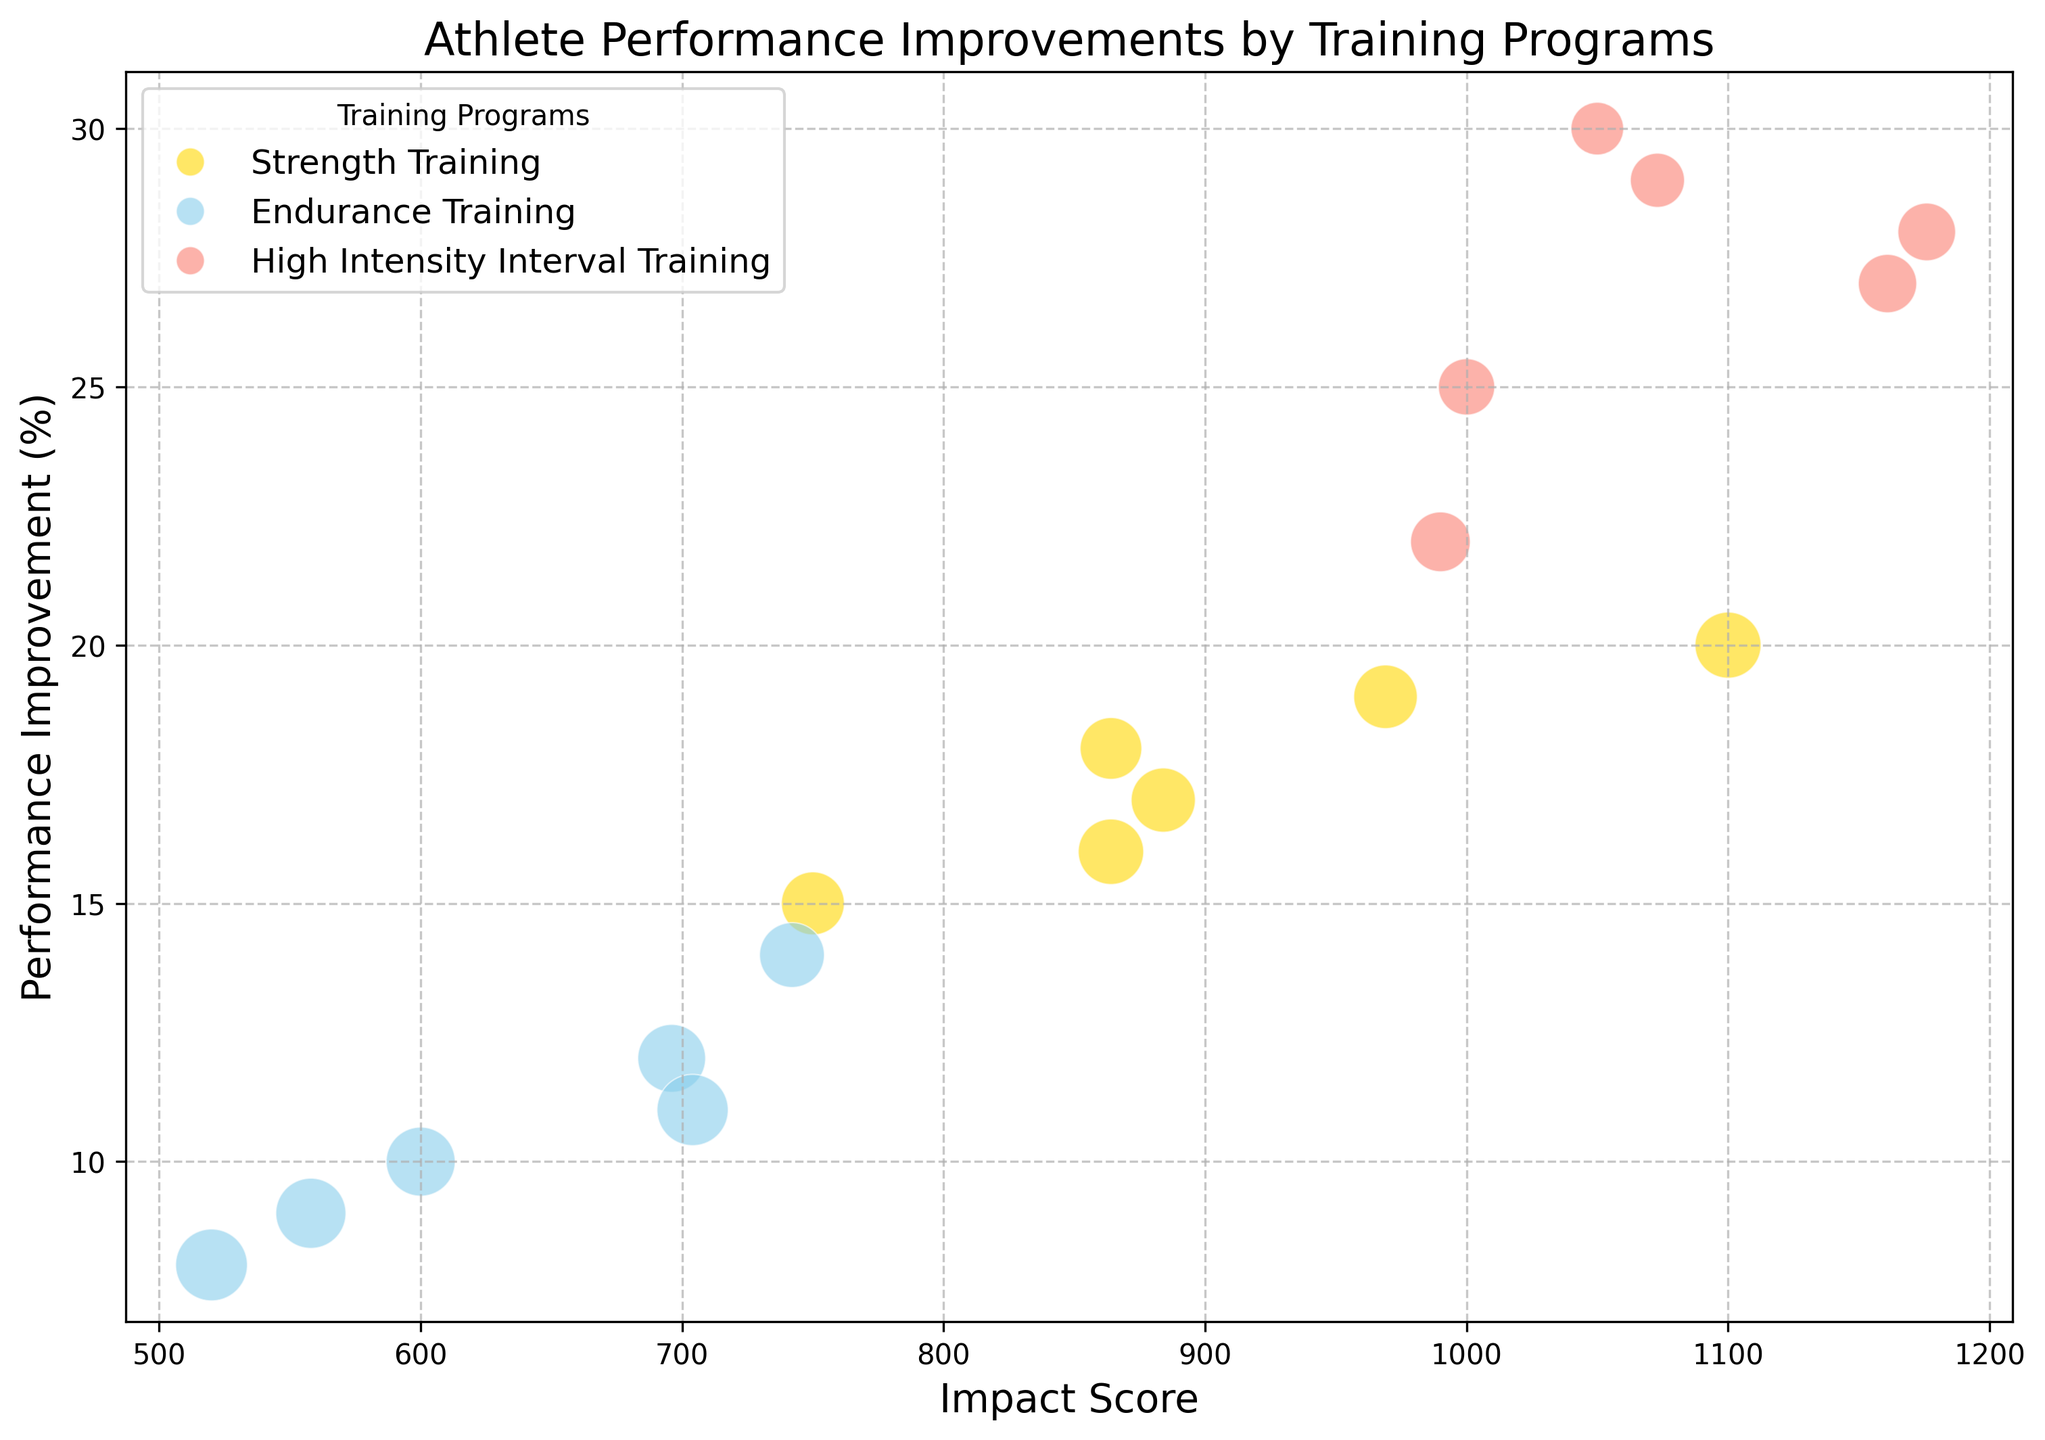What is the highest Performance Improvement observed among athletes? To find the highest Performance Improvement, we scan the vertical axis for the highest point. It appears to be associated with David White, showing a Performance Improvement of 30%.
Answer: 30% Which Training Program has the largest bubble size in general and what does it represent? Larger bubble size corresponds to higher Frequency. By examining the bubbles, the largest bubbles are generally found in the High Intensity Interval Training program. For instance, David White’s and Angela Lewis' bubbles are large.
Answer: High Intensity Interval Training What is the Performance Improvement for an athlete with the highest Impact Score? David White has the highest Impact Score of 1050. Scanning vertically from this point on the horizontal axis, we identify the Performance Improvement as 30%.
Answer: 30% Among athletes in Endurance Training, who shows the highest Performance Improvement and what is the value? Focusing on the blue bubbles representing Endurance Training, Robert Clark achieves the highest Performance Improvement with a value of 14%.
Answer: 14% Which Training Program has the widest range of Impact Scores? By examining the spread along the horizontal axis, High Intensity Interval Training presents the widest range, stretching from approximately 990 to 1176.
Answer: High Intensity Interval Training What is the average Performance Improvement of athletes in Strength Training program? Strength Training improvements are 15, 20, 18, 17, 19, 16. Summing these up yields 105. Divided by 6 athletes, the average is 105/6 = 17.5%.
Answer: 17.5% Which Training Program shows overall higher Performance Improvements, comparing Strength Training and Endurance Training? By comparing the vertical distribution of gold and blue bubbles, Strength Training generally shows higher Performance Improvements with many values around 17-20% compared to Endurance Training which is mostly around 8-14%.
Answer: Strength Training Which Training Program has the greatest consistency in Performance Improvement among its athletes? Consistency means less variation. Strength Training and Endurance Training have smaller spans. However, Endurance Training varies less, with improvements mainly between 8-14%.
Answer: Endurance Training What is the Performance Improvement and Frequency for the athlete with the smallest bubble size? The smallest bubble corresponds to the lowest frequency. Michael Brown's bubble is the smallest, with a Frequency of 35 and a Performance Improvement of 8%.
Answer: 8%, 35 Comparing Jane Smith and Sarah Moore, who has the higher Impact Score and by how much? Jane Smith's Impact Score is 600, while Sarah Moore's is 696. The difference is 696 - 600 = 96.
Answer: Sarah Moore, 96 